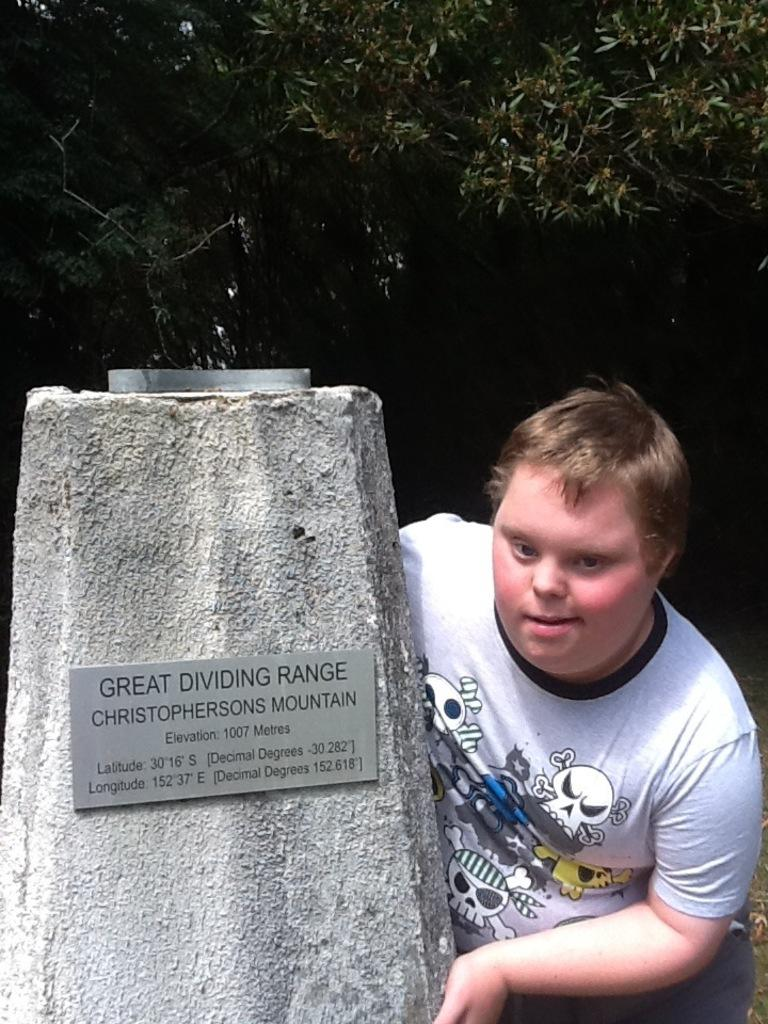What is the main subject of the image? There is a person in the image. What structure is present near the person? There is a pillar with a name board in the image. What can be seen in the background of the image? There are trees in the background of the image. What type of blood is visible on the person's clothes in the image? There is no blood visible on the person's clothes in the image. How many snakes can be seen slithering around the pillar in the image? There are no snakes present in the image. 